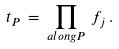<formula> <loc_0><loc_0><loc_500><loc_500>t _ { P } \, = \, \prod _ { a l o n g P } \, f _ { j } \, .</formula> 